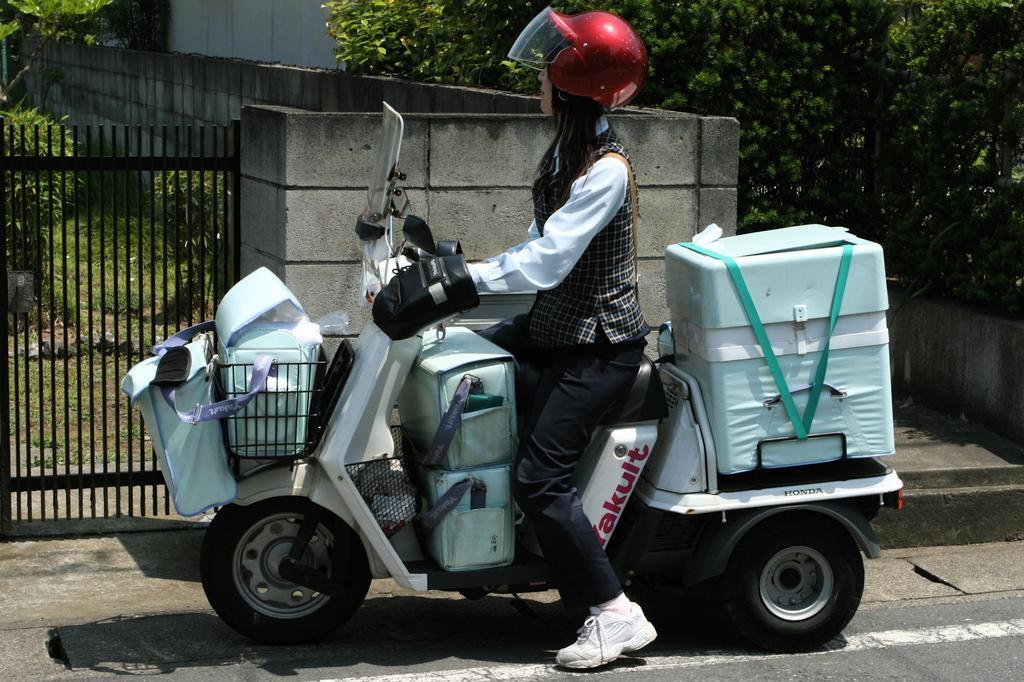Describe this image in one or two sentences. In this image, I can see a woman with a helmet and gloves and she is sitting on a motorbike with the bags. On the left side of the image, I can see an iron gate. There are trees, plants and the wall. 